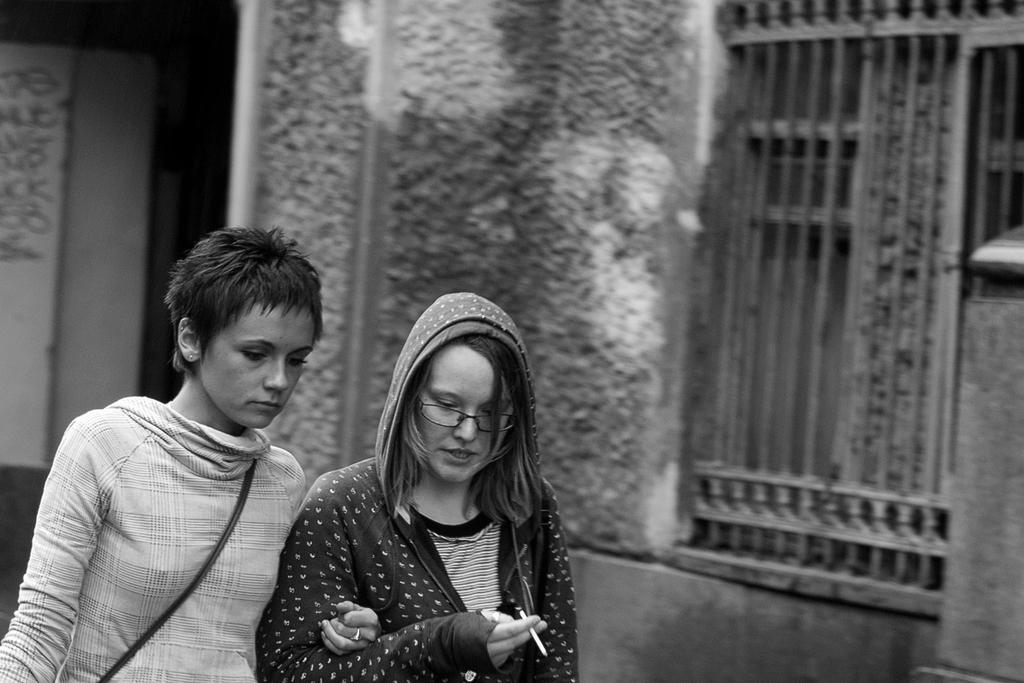How many people are present in the image? There are two persons standing in the image. What can be seen in the background of the image? There is a building in the background of the image. What type of wrench is being used by the persons in the image? There is no wrench present in the image; the two persons are simply standing. What kind of wine is being served at the event in the image? There is no event or wine present in the image; it only features two persons standing and a building in the background. 